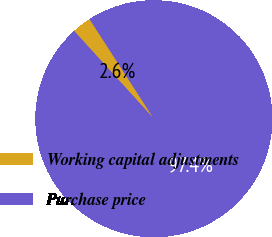Convert chart. <chart><loc_0><loc_0><loc_500><loc_500><pie_chart><fcel>Working capital adjustments<fcel>Purchase price<nl><fcel>2.61%<fcel>97.39%<nl></chart> 